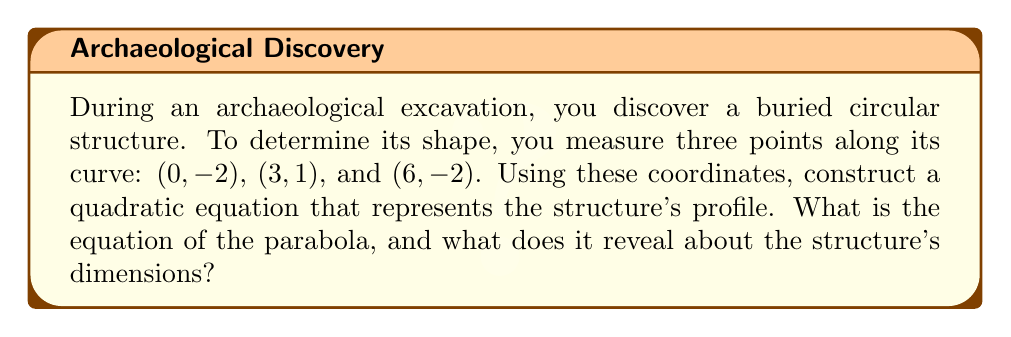Show me your answer to this math problem. To solve this problem, we'll follow these steps:

1) The general form of a quadratic equation is $y = ax^2 + bx + c$, where $a$, $b$, and $c$ are constants and $a \neq 0$.

2) We have three points: (0, -2), (3, 1), and (6, -2). Let's substitute these into the general equation:

   For (0, -2): $-2 = a(0)^2 + b(0) + c$, simplifies to $-2 = c$
   For (3, 1):  $1 = a(3)^2 + b(3) + c$, or $1 = 9a + 3b - 2$
   For (6, -2): $-2 = a(6)^2 + b(6) + c$, or $-2 = 36a + 6b - 2$

3) From the first equation, we know that $c = -2$. Substitute this into the other two equations:

   $1 = 9a + 3b$
   $0 = 36a + 6b$

4) Multiply the first equation by 2 and the second by -1:

   $2 = 18a + 6b$
   $0 = -36a - 6b$

5) Add these equations:

   $2 = -18a$

6) Solve for $a$:

   $a = -\frac{1}{9}$

7) Substitute this back into $1 = 9a + 3b$ to solve for $b$:

   $1 = 9(-\frac{1}{9}) + 3b$
   $1 = -1 + 3b$
   $2 = 3b$
   $b = \frac{2}{3}$

8) Now we have $a$, $b$, and $c$. The equation of the parabola is:

   $y = -\frac{1}{9}x^2 + \frac{2}{3}x - 2$

9) To interpret this:
   - The negative $a$ value (-1/9) indicates the parabola opens downward.
   - The axis of symmetry is at $x = -\frac{b}{2a} = -\frac{2/3}{2(-1/9)} = 3$.
   - The vertex is at (3, 1), which is the highest point of the structure.
   - The y-intercept (c) is -2, indicating the depth of the structure at its edges.

This parabola represents a circular structure with a diameter of 6 units (from x=0 to x=6) and a maximum height of 3 units above the lowest point.
Answer: The equation of the parabola is $y = -\frac{1}{9}x^2 + \frac{2}{3}x - 2$. This reveals a circular structure with a diameter of 6 units and a maximum height of 3 units above its base. 